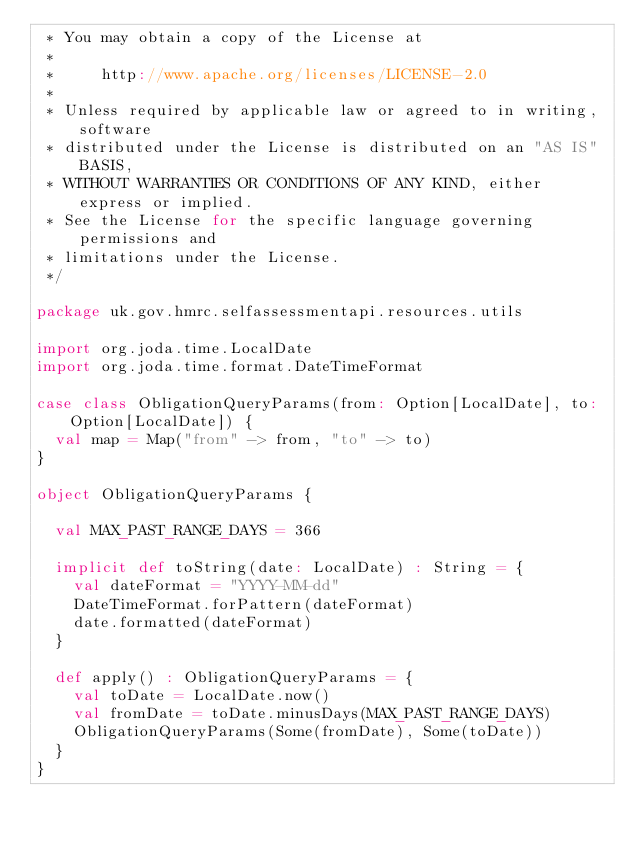Convert code to text. <code><loc_0><loc_0><loc_500><loc_500><_Scala_> * You may obtain a copy of the License at
 *
 *     http://www.apache.org/licenses/LICENSE-2.0
 *
 * Unless required by applicable law or agreed to in writing, software
 * distributed under the License is distributed on an "AS IS" BASIS,
 * WITHOUT WARRANTIES OR CONDITIONS OF ANY KIND, either express or implied.
 * See the License for the specific language governing permissions and
 * limitations under the License.
 */

package uk.gov.hmrc.selfassessmentapi.resources.utils

import org.joda.time.LocalDate
import org.joda.time.format.DateTimeFormat

case class ObligationQueryParams(from: Option[LocalDate], to: Option[LocalDate]) {
  val map = Map("from" -> from, "to" -> to)
}

object ObligationQueryParams {

  val MAX_PAST_RANGE_DAYS = 366

  implicit def toString(date: LocalDate) : String = {
    val dateFormat = "YYYY-MM-dd"
    DateTimeFormat.forPattern(dateFormat)
    date.formatted(dateFormat)
  }

  def apply() : ObligationQueryParams = {
    val toDate = LocalDate.now()
    val fromDate = toDate.minusDays(MAX_PAST_RANGE_DAYS)
    ObligationQueryParams(Some(fromDate), Some(toDate))
  }
}


</code> 